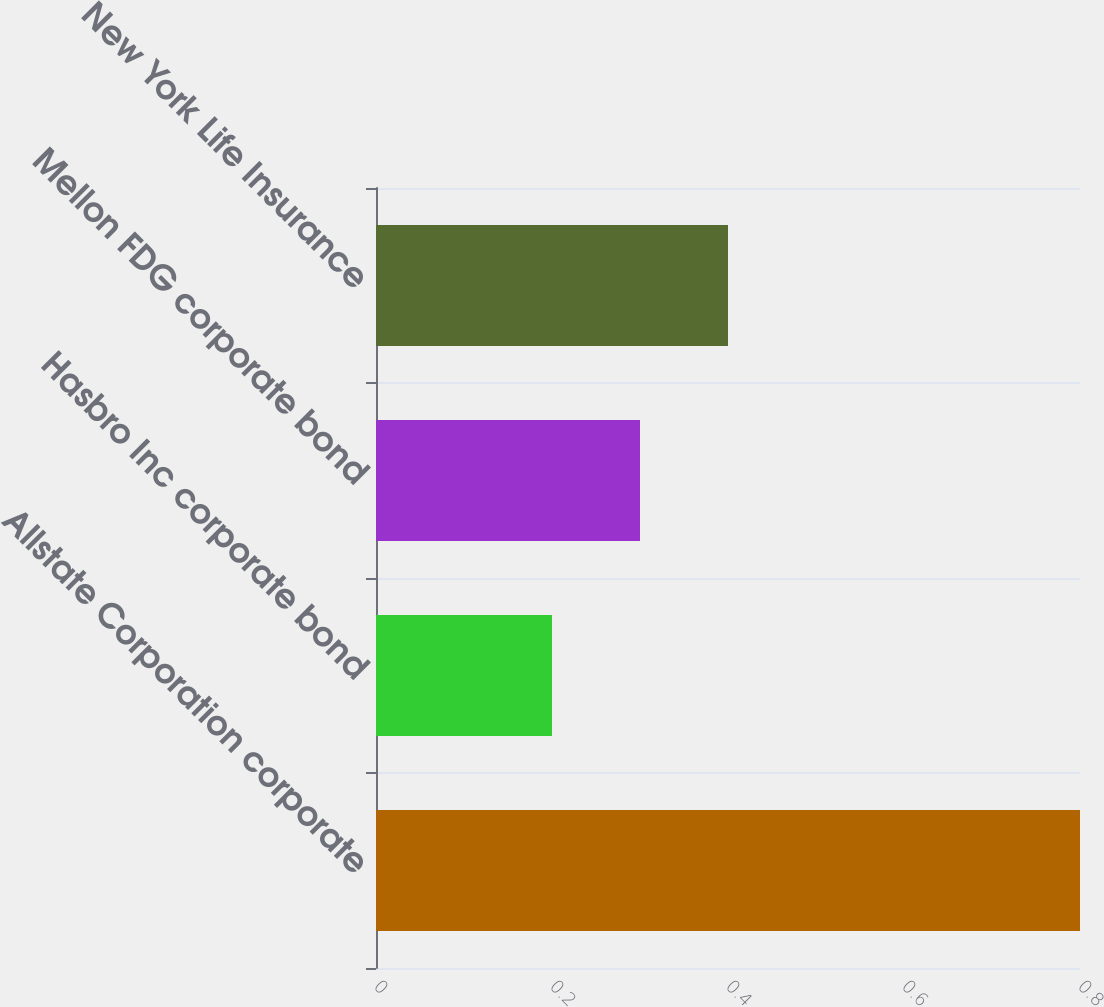Convert chart to OTSL. <chart><loc_0><loc_0><loc_500><loc_500><bar_chart><fcel>Allstate Corporation corporate<fcel>Hasbro Inc corporate bond<fcel>Mellon FDG corporate bond<fcel>New York Life Insurance<nl><fcel>0.8<fcel>0.2<fcel>0.3<fcel>0.4<nl></chart> 